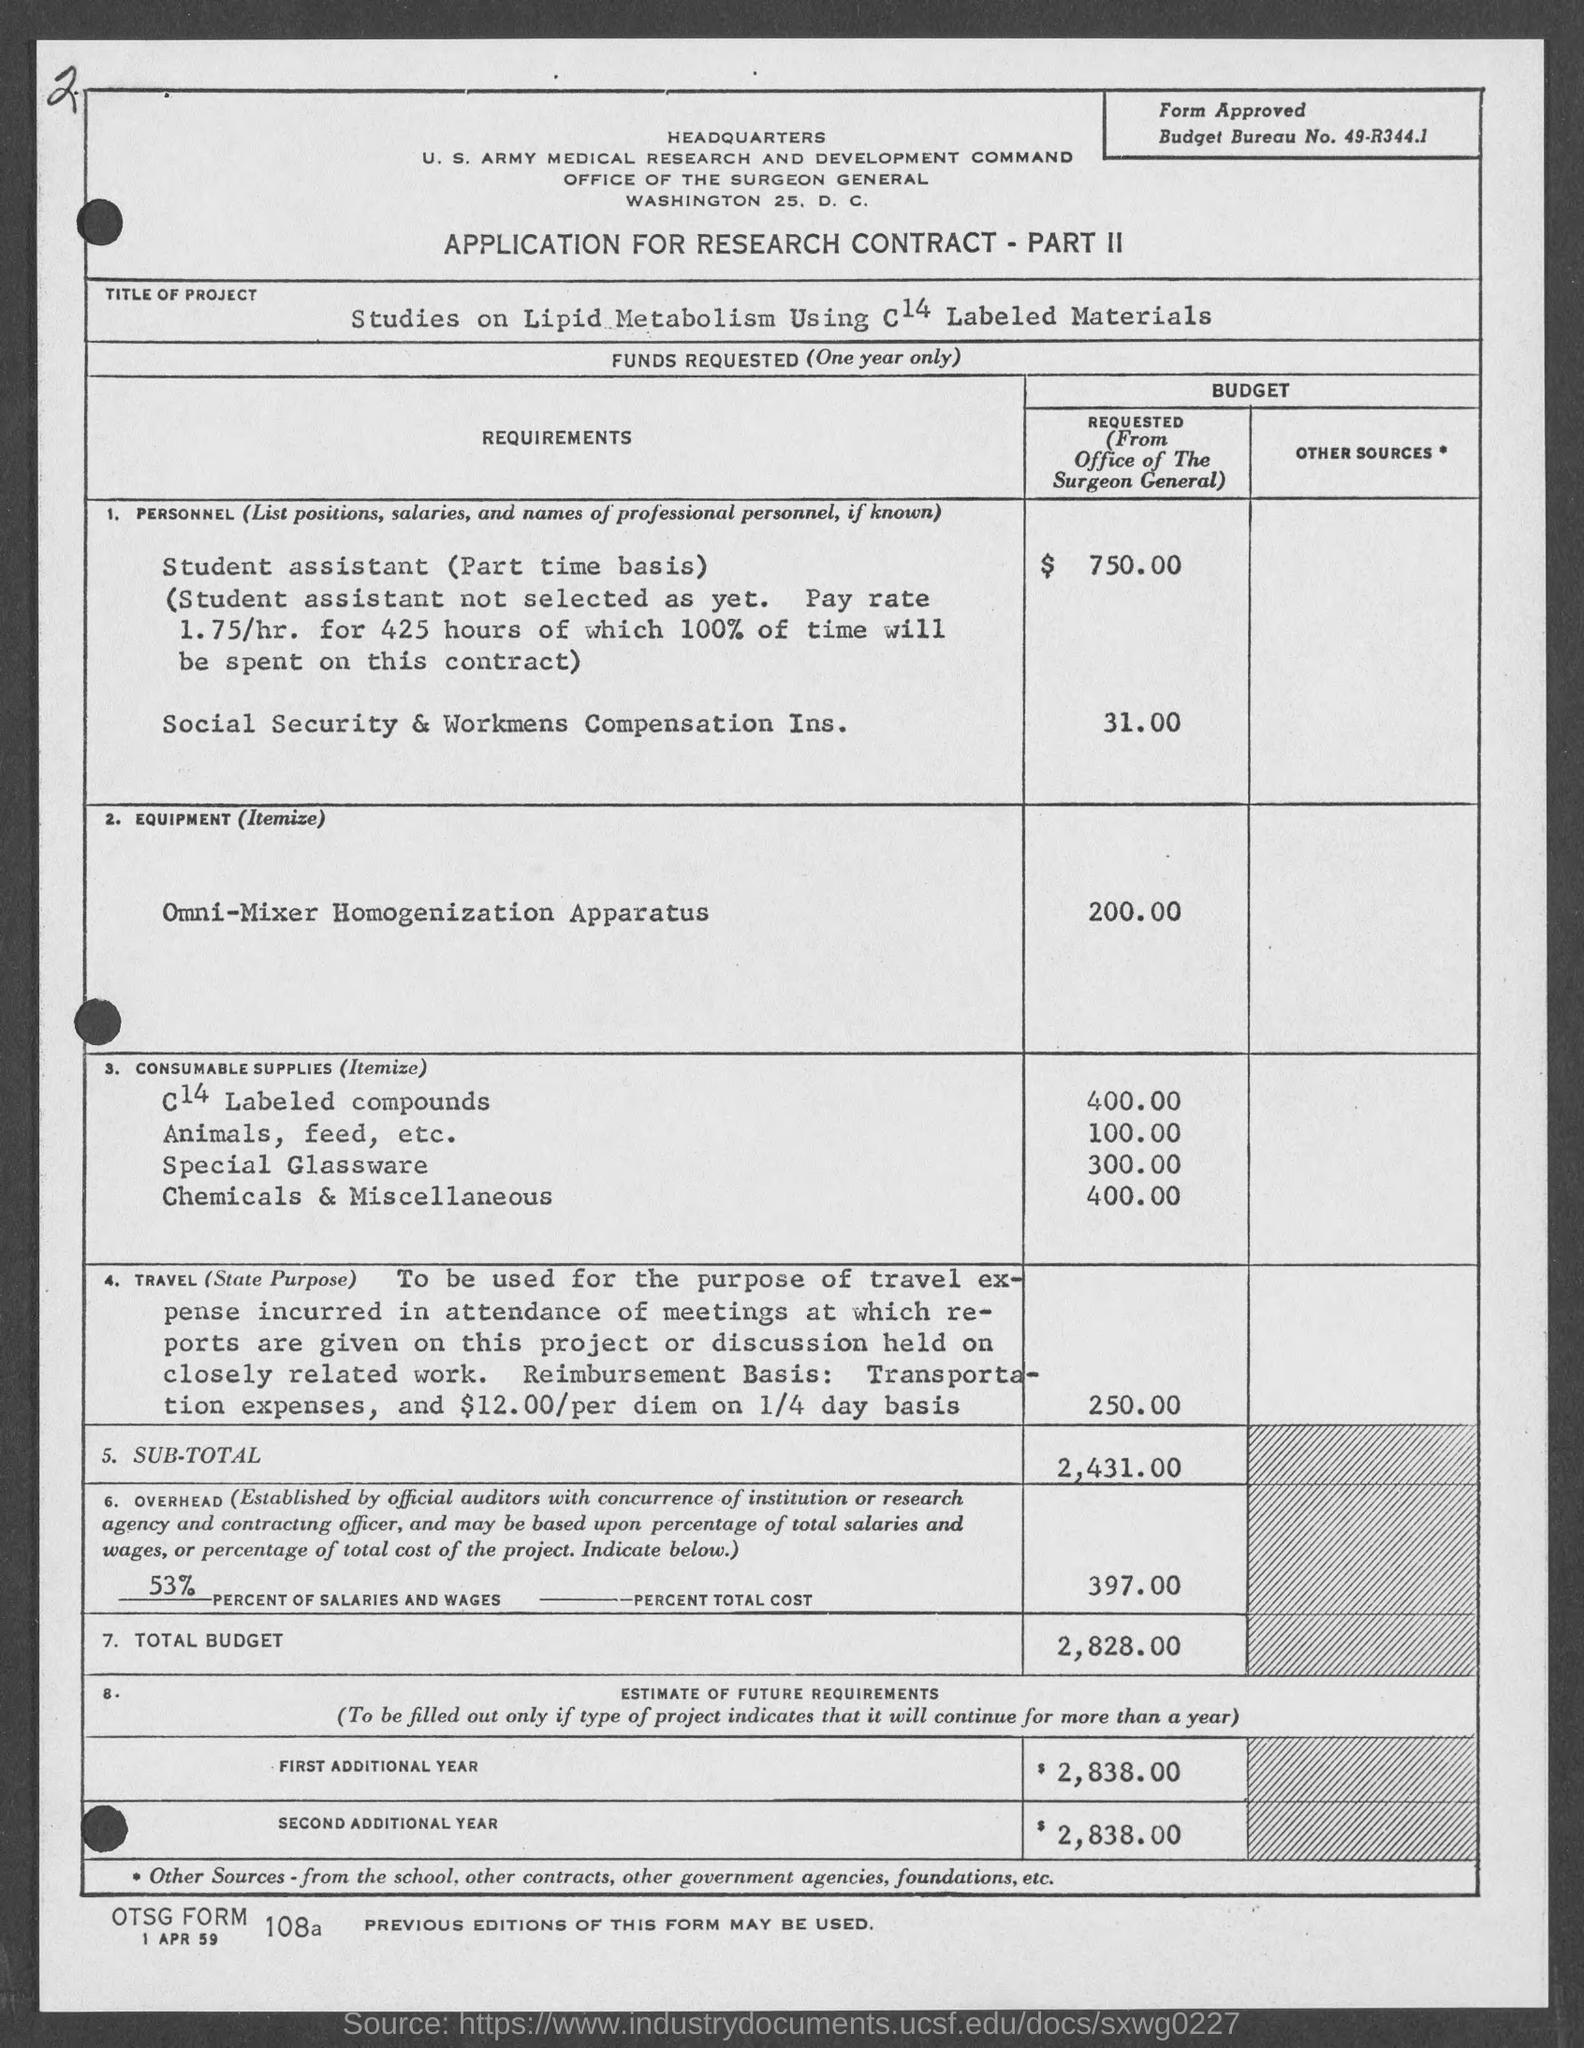What kind of application is given here?
Ensure brevity in your answer.  APPLICATION FOR RESEARCH CONTRACT - PART II. What is the Budget Bureau No. given in the application?
Make the answer very short. 49-R344.1. What is the budget requested for Omni- Mixer Homogenization Apparatus?
Provide a short and direct response. 200.00. What is the total budget requested from office of the Surgeon General?
Make the answer very short. $ 2,828.00. What is the budget requested for Social Security & Workmens Compensation Ins.?
Keep it short and to the point. $ 31.00. 